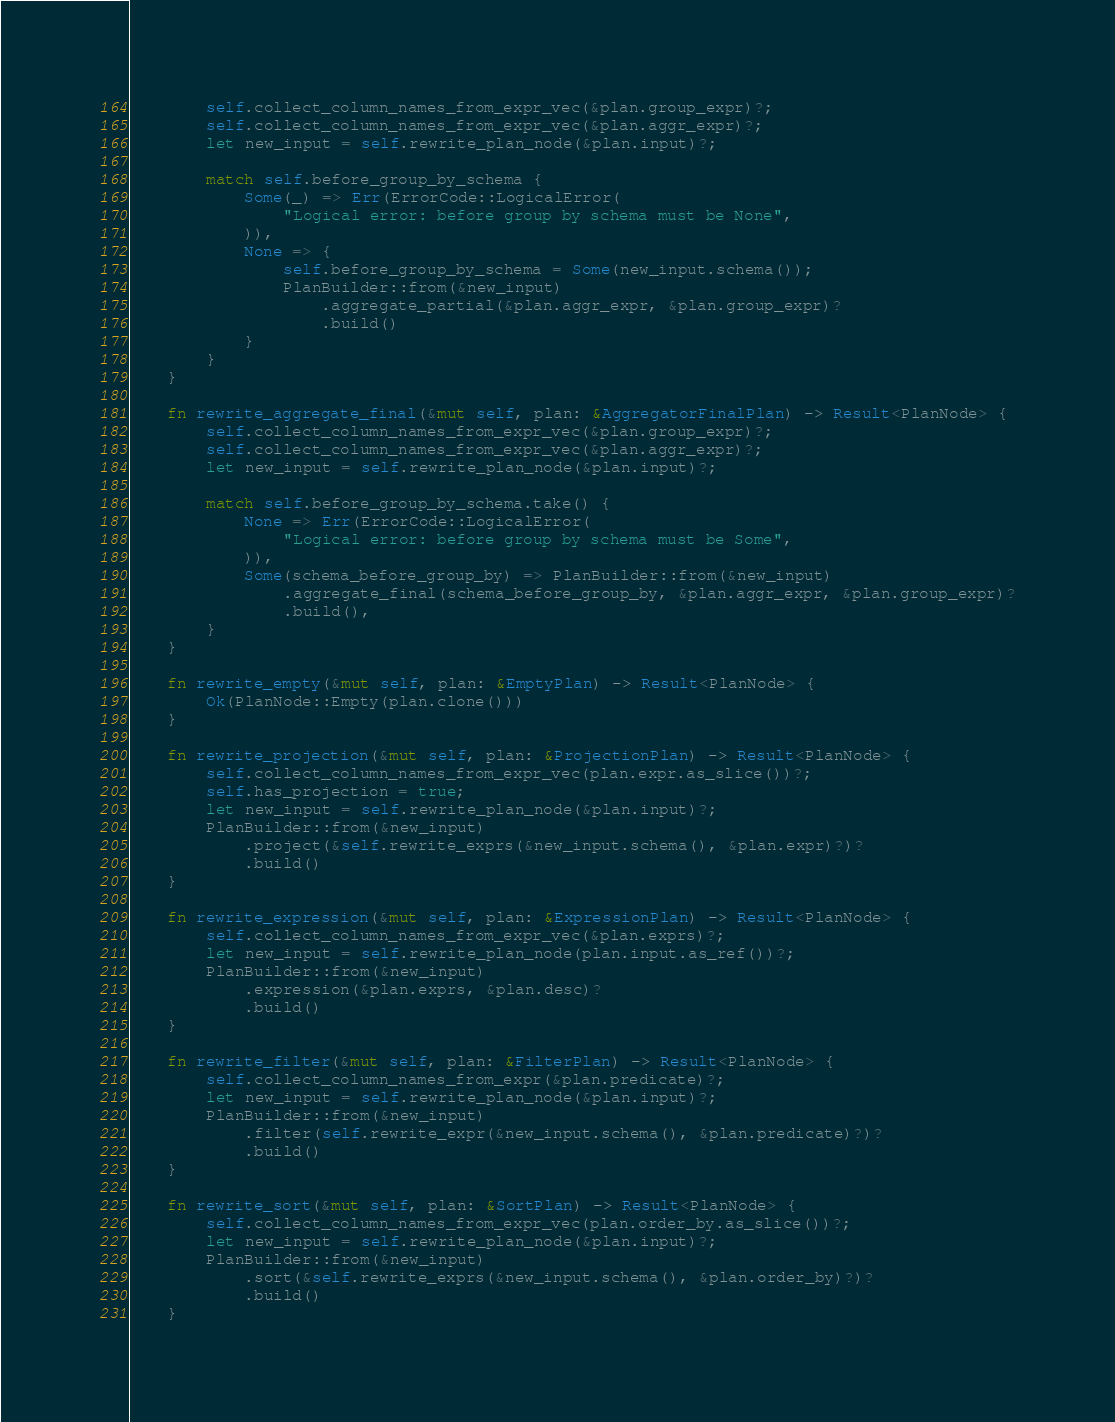<code> <loc_0><loc_0><loc_500><loc_500><_Rust_>        self.collect_column_names_from_expr_vec(&plan.group_expr)?;
        self.collect_column_names_from_expr_vec(&plan.aggr_expr)?;
        let new_input = self.rewrite_plan_node(&plan.input)?;

        match self.before_group_by_schema {
            Some(_) => Err(ErrorCode::LogicalError(
                "Logical error: before group by schema must be None",
            )),
            None => {
                self.before_group_by_schema = Some(new_input.schema());
                PlanBuilder::from(&new_input)
                    .aggregate_partial(&plan.aggr_expr, &plan.group_expr)?
                    .build()
            }
        }
    }

    fn rewrite_aggregate_final(&mut self, plan: &AggregatorFinalPlan) -> Result<PlanNode> {
        self.collect_column_names_from_expr_vec(&plan.group_expr)?;
        self.collect_column_names_from_expr_vec(&plan.aggr_expr)?;
        let new_input = self.rewrite_plan_node(&plan.input)?;

        match self.before_group_by_schema.take() {
            None => Err(ErrorCode::LogicalError(
                "Logical error: before group by schema must be Some",
            )),
            Some(schema_before_group_by) => PlanBuilder::from(&new_input)
                .aggregate_final(schema_before_group_by, &plan.aggr_expr, &plan.group_expr)?
                .build(),
        }
    }

    fn rewrite_empty(&mut self, plan: &EmptyPlan) -> Result<PlanNode> {
        Ok(PlanNode::Empty(plan.clone()))
    }

    fn rewrite_projection(&mut self, plan: &ProjectionPlan) -> Result<PlanNode> {
        self.collect_column_names_from_expr_vec(plan.expr.as_slice())?;
        self.has_projection = true;
        let new_input = self.rewrite_plan_node(&plan.input)?;
        PlanBuilder::from(&new_input)
            .project(&self.rewrite_exprs(&new_input.schema(), &plan.expr)?)?
            .build()
    }

    fn rewrite_expression(&mut self, plan: &ExpressionPlan) -> Result<PlanNode> {
        self.collect_column_names_from_expr_vec(&plan.exprs)?;
        let new_input = self.rewrite_plan_node(plan.input.as_ref())?;
        PlanBuilder::from(&new_input)
            .expression(&plan.exprs, &plan.desc)?
            .build()
    }

    fn rewrite_filter(&mut self, plan: &FilterPlan) -> Result<PlanNode> {
        self.collect_column_names_from_expr(&plan.predicate)?;
        let new_input = self.rewrite_plan_node(&plan.input)?;
        PlanBuilder::from(&new_input)
            .filter(self.rewrite_expr(&new_input.schema(), &plan.predicate)?)?
            .build()
    }

    fn rewrite_sort(&mut self, plan: &SortPlan) -> Result<PlanNode> {
        self.collect_column_names_from_expr_vec(plan.order_by.as_slice())?;
        let new_input = self.rewrite_plan_node(&plan.input)?;
        PlanBuilder::from(&new_input)
            .sort(&self.rewrite_exprs(&new_input.schema(), &plan.order_by)?)?
            .build()
    }
</code> 